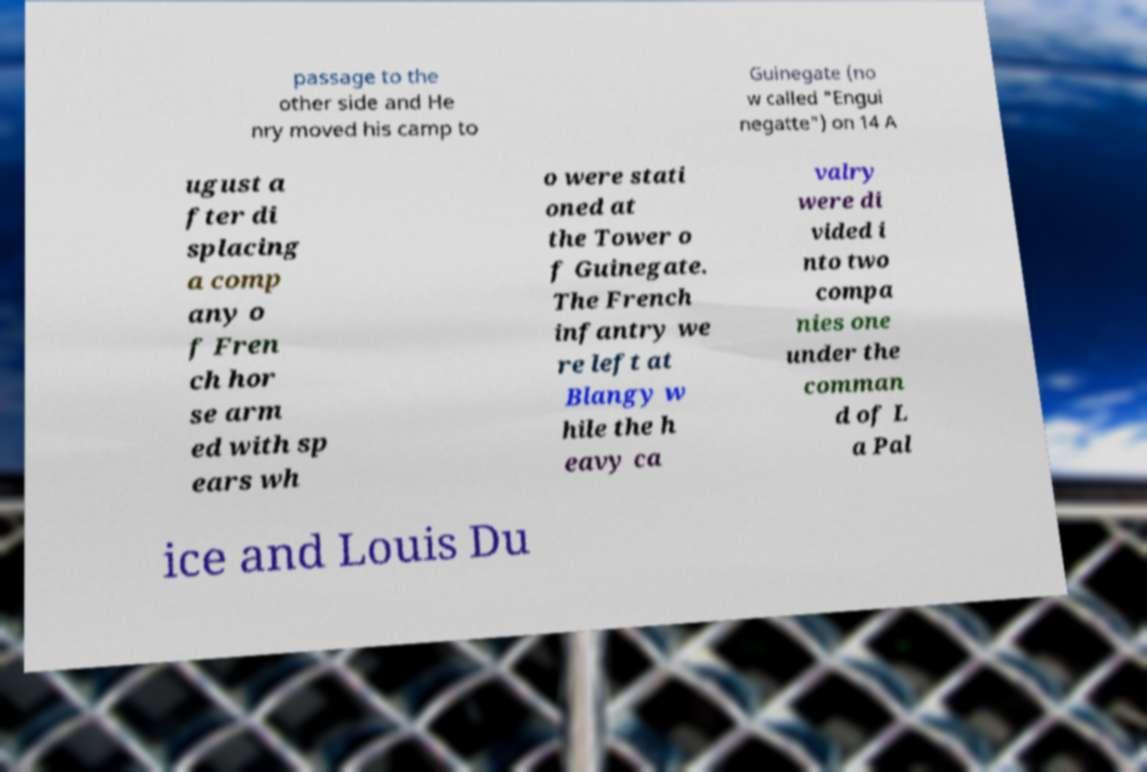Please read and relay the text visible in this image. What does it say? passage to the other side and He nry moved his camp to Guinegate (no w called "Engui negatte") on 14 A ugust a fter di splacing a comp any o f Fren ch hor se arm ed with sp ears wh o were stati oned at the Tower o f Guinegate. The French infantry we re left at Blangy w hile the h eavy ca valry were di vided i nto two compa nies one under the comman d of L a Pal ice and Louis Du 